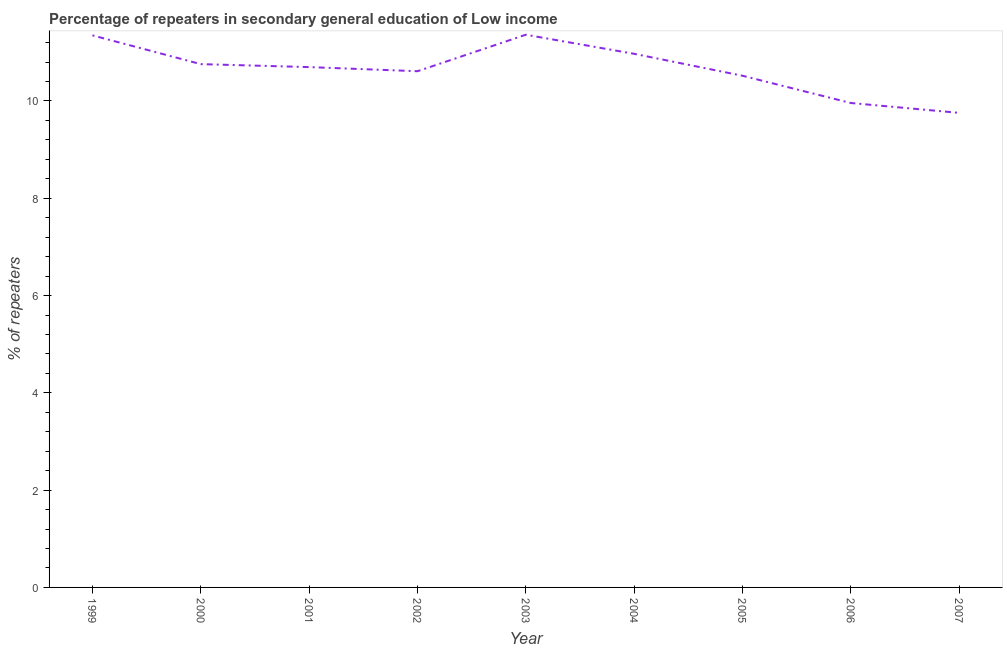What is the percentage of repeaters in 2003?
Offer a very short reply. 11.36. Across all years, what is the maximum percentage of repeaters?
Your response must be concise. 11.36. Across all years, what is the minimum percentage of repeaters?
Keep it short and to the point. 9.76. What is the sum of the percentage of repeaters?
Your answer should be very brief. 95.98. What is the difference between the percentage of repeaters in 2003 and 2006?
Your response must be concise. 1.4. What is the average percentage of repeaters per year?
Give a very brief answer. 10.66. What is the median percentage of repeaters?
Your response must be concise. 10.7. Do a majority of the years between 2001 and 2002 (inclusive) have percentage of repeaters greater than 5.6 %?
Provide a succinct answer. Yes. What is the ratio of the percentage of repeaters in 2005 to that in 2007?
Your answer should be very brief. 1.08. What is the difference between the highest and the second highest percentage of repeaters?
Offer a very short reply. 0.01. Is the sum of the percentage of repeaters in 1999 and 2002 greater than the maximum percentage of repeaters across all years?
Give a very brief answer. Yes. What is the difference between the highest and the lowest percentage of repeaters?
Make the answer very short. 1.61. In how many years, is the percentage of repeaters greater than the average percentage of repeaters taken over all years?
Offer a very short reply. 5. Does the percentage of repeaters monotonically increase over the years?
Make the answer very short. No. How many years are there in the graph?
Give a very brief answer. 9. Does the graph contain any zero values?
Offer a terse response. No. What is the title of the graph?
Provide a succinct answer. Percentage of repeaters in secondary general education of Low income. What is the label or title of the Y-axis?
Provide a succinct answer. % of repeaters. What is the % of repeaters in 1999?
Provide a succinct answer. 11.35. What is the % of repeaters of 2000?
Provide a short and direct response. 10.76. What is the % of repeaters of 2001?
Make the answer very short. 10.7. What is the % of repeaters of 2002?
Your response must be concise. 10.61. What is the % of repeaters in 2003?
Provide a short and direct response. 11.36. What is the % of repeaters in 2004?
Your answer should be compact. 10.97. What is the % of repeaters in 2005?
Offer a terse response. 10.52. What is the % of repeaters in 2006?
Your response must be concise. 9.96. What is the % of repeaters of 2007?
Give a very brief answer. 9.76. What is the difference between the % of repeaters in 1999 and 2000?
Provide a succinct answer. 0.59. What is the difference between the % of repeaters in 1999 and 2001?
Your answer should be very brief. 0.65. What is the difference between the % of repeaters in 1999 and 2002?
Your response must be concise. 0.74. What is the difference between the % of repeaters in 1999 and 2003?
Provide a short and direct response. -0.01. What is the difference between the % of repeaters in 1999 and 2004?
Your answer should be very brief. 0.38. What is the difference between the % of repeaters in 1999 and 2005?
Give a very brief answer. 0.83. What is the difference between the % of repeaters in 1999 and 2006?
Provide a succinct answer. 1.39. What is the difference between the % of repeaters in 1999 and 2007?
Keep it short and to the point. 1.59. What is the difference between the % of repeaters in 2000 and 2001?
Make the answer very short. 0.06. What is the difference between the % of repeaters in 2000 and 2002?
Keep it short and to the point. 0.15. What is the difference between the % of repeaters in 2000 and 2003?
Provide a succinct answer. -0.6. What is the difference between the % of repeaters in 2000 and 2004?
Offer a very short reply. -0.21. What is the difference between the % of repeaters in 2000 and 2005?
Ensure brevity in your answer.  0.24. What is the difference between the % of repeaters in 2000 and 2006?
Offer a terse response. 0.8. What is the difference between the % of repeaters in 2000 and 2007?
Your answer should be very brief. 1. What is the difference between the % of repeaters in 2001 and 2002?
Ensure brevity in your answer.  0.08. What is the difference between the % of repeaters in 2001 and 2003?
Ensure brevity in your answer.  -0.67. What is the difference between the % of repeaters in 2001 and 2004?
Ensure brevity in your answer.  -0.27. What is the difference between the % of repeaters in 2001 and 2005?
Keep it short and to the point. 0.18. What is the difference between the % of repeaters in 2001 and 2006?
Ensure brevity in your answer.  0.74. What is the difference between the % of repeaters in 2001 and 2007?
Provide a succinct answer. 0.94. What is the difference between the % of repeaters in 2002 and 2003?
Provide a succinct answer. -0.75. What is the difference between the % of repeaters in 2002 and 2004?
Ensure brevity in your answer.  -0.36. What is the difference between the % of repeaters in 2002 and 2005?
Offer a terse response. 0.09. What is the difference between the % of repeaters in 2002 and 2006?
Give a very brief answer. 0.65. What is the difference between the % of repeaters in 2002 and 2007?
Provide a succinct answer. 0.86. What is the difference between the % of repeaters in 2003 and 2004?
Your answer should be very brief. 0.39. What is the difference between the % of repeaters in 2003 and 2005?
Your answer should be very brief. 0.84. What is the difference between the % of repeaters in 2003 and 2006?
Provide a short and direct response. 1.4. What is the difference between the % of repeaters in 2003 and 2007?
Ensure brevity in your answer.  1.61. What is the difference between the % of repeaters in 2004 and 2005?
Give a very brief answer. 0.45. What is the difference between the % of repeaters in 2004 and 2006?
Provide a short and direct response. 1.01. What is the difference between the % of repeaters in 2004 and 2007?
Make the answer very short. 1.21. What is the difference between the % of repeaters in 2005 and 2006?
Offer a very short reply. 0.56. What is the difference between the % of repeaters in 2005 and 2007?
Offer a very short reply. 0.76. What is the difference between the % of repeaters in 2006 and 2007?
Ensure brevity in your answer.  0.2. What is the ratio of the % of repeaters in 1999 to that in 2000?
Offer a very short reply. 1.05. What is the ratio of the % of repeaters in 1999 to that in 2001?
Give a very brief answer. 1.06. What is the ratio of the % of repeaters in 1999 to that in 2002?
Offer a terse response. 1.07. What is the ratio of the % of repeaters in 1999 to that in 2003?
Keep it short and to the point. 1. What is the ratio of the % of repeaters in 1999 to that in 2004?
Your answer should be very brief. 1.03. What is the ratio of the % of repeaters in 1999 to that in 2005?
Make the answer very short. 1.08. What is the ratio of the % of repeaters in 1999 to that in 2006?
Give a very brief answer. 1.14. What is the ratio of the % of repeaters in 1999 to that in 2007?
Provide a short and direct response. 1.16. What is the ratio of the % of repeaters in 2000 to that in 2002?
Offer a very short reply. 1.01. What is the ratio of the % of repeaters in 2000 to that in 2003?
Provide a short and direct response. 0.95. What is the ratio of the % of repeaters in 2000 to that in 2005?
Make the answer very short. 1.02. What is the ratio of the % of repeaters in 2000 to that in 2007?
Your answer should be compact. 1.1. What is the ratio of the % of repeaters in 2001 to that in 2002?
Your answer should be compact. 1.01. What is the ratio of the % of repeaters in 2001 to that in 2003?
Provide a short and direct response. 0.94. What is the ratio of the % of repeaters in 2001 to that in 2006?
Offer a very short reply. 1.07. What is the ratio of the % of repeaters in 2001 to that in 2007?
Give a very brief answer. 1.1. What is the ratio of the % of repeaters in 2002 to that in 2003?
Your answer should be compact. 0.93. What is the ratio of the % of repeaters in 2002 to that in 2006?
Provide a succinct answer. 1.07. What is the ratio of the % of repeaters in 2002 to that in 2007?
Your response must be concise. 1.09. What is the ratio of the % of repeaters in 2003 to that in 2004?
Make the answer very short. 1.04. What is the ratio of the % of repeaters in 2003 to that in 2006?
Provide a short and direct response. 1.14. What is the ratio of the % of repeaters in 2003 to that in 2007?
Offer a terse response. 1.17. What is the ratio of the % of repeaters in 2004 to that in 2005?
Your response must be concise. 1.04. What is the ratio of the % of repeaters in 2004 to that in 2006?
Keep it short and to the point. 1.1. What is the ratio of the % of repeaters in 2004 to that in 2007?
Your answer should be compact. 1.12. What is the ratio of the % of repeaters in 2005 to that in 2006?
Ensure brevity in your answer.  1.06. What is the ratio of the % of repeaters in 2005 to that in 2007?
Ensure brevity in your answer.  1.08. What is the ratio of the % of repeaters in 2006 to that in 2007?
Offer a terse response. 1.02. 